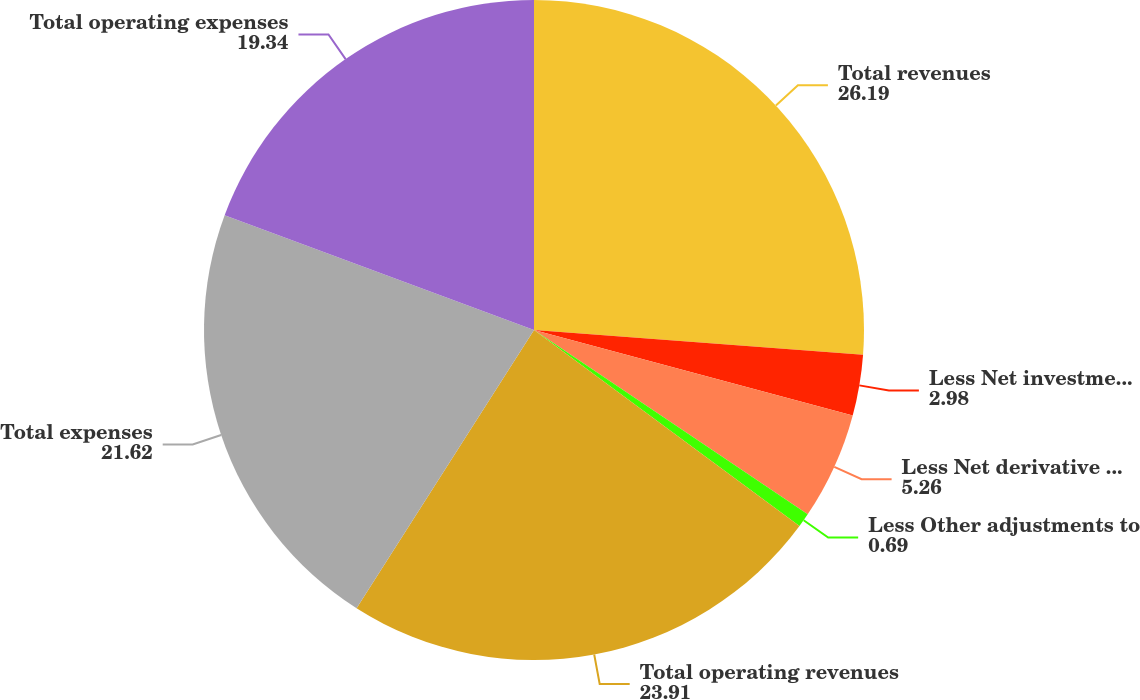<chart> <loc_0><loc_0><loc_500><loc_500><pie_chart><fcel>Total revenues<fcel>Less Net investment gains<fcel>Less Net derivative gains<fcel>Less Other adjustments to<fcel>Total operating revenues<fcel>Total expenses<fcel>Total operating expenses<nl><fcel>26.19%<fcel>2.98%<fcel>5.26%<fcel>0.69%<fcel>23.91%<fcel>21.62%<fcel>19.34%<nl></chart> 